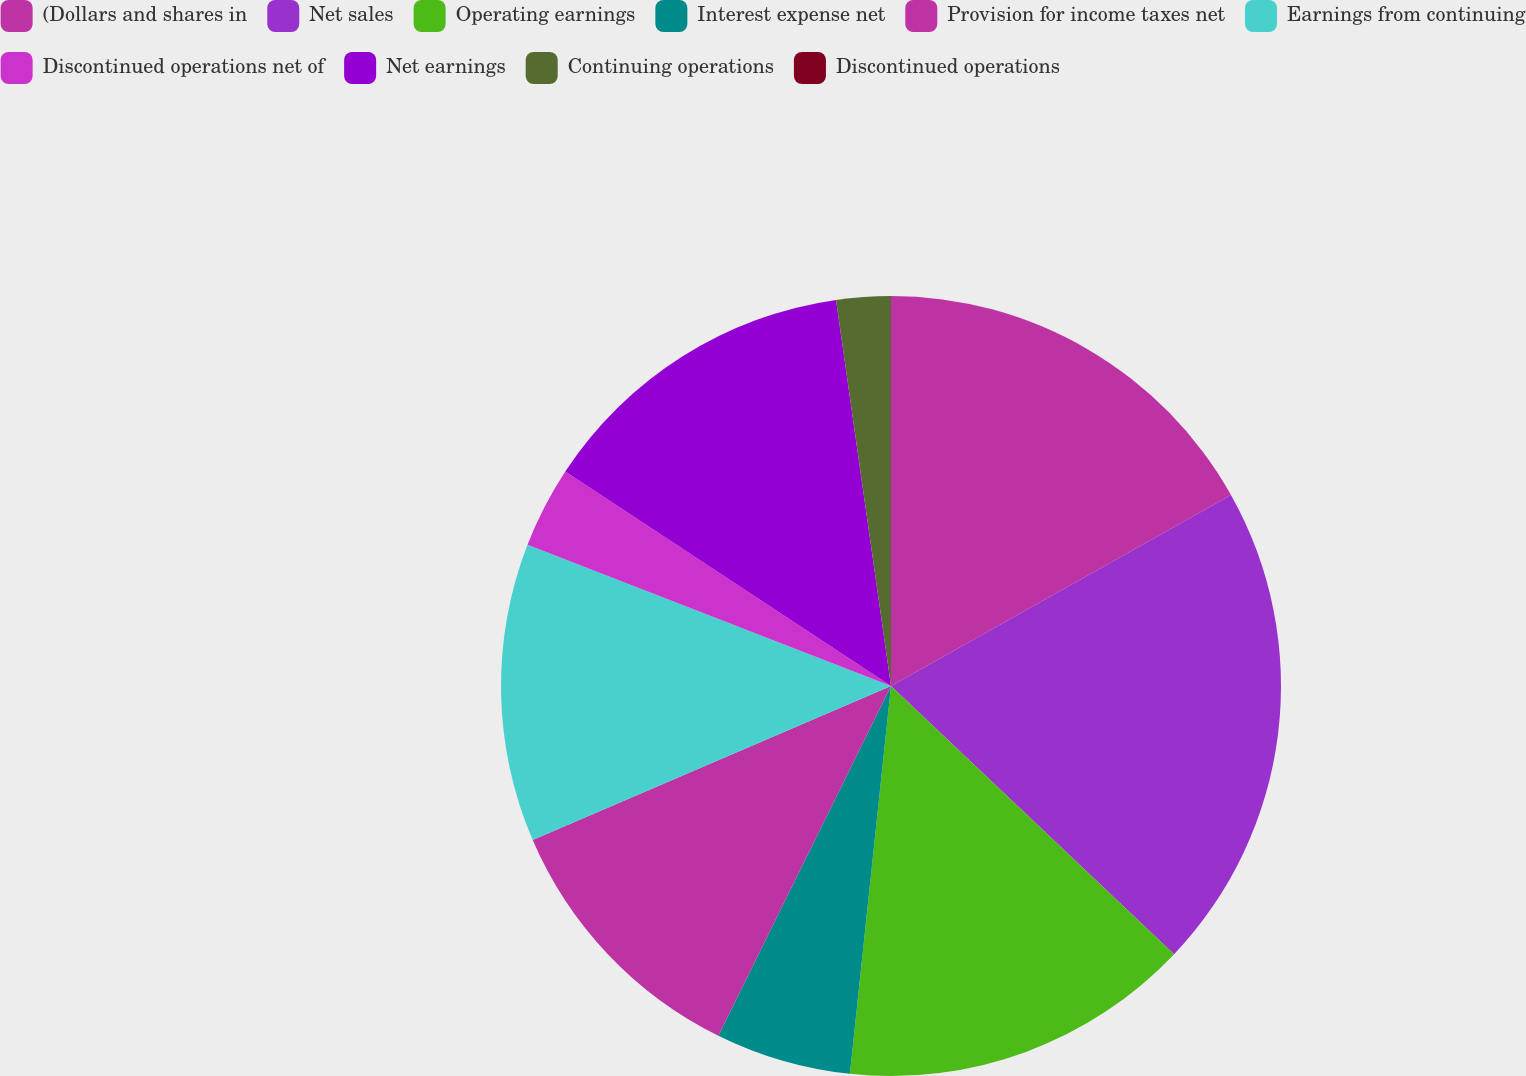Convert chart to OTSL. <chart><loc_0><loc_0><loc_500><loc_500><pie_chart><fcel>(Dollars and shares in<fcel>Net sales<fcel>Operating earnings<fcel>Interest expense net<fcel>Provision for income taxes net<fcel>Earnings from continuing<fcel>Discontinued operations net of<fcel>Net earnings<fcel>Continuing operations<fcel>Discontinued operations<nl><fcel>16.85%<fcel>20.22%<fcel>14.61%<fcel>5.62%<fcel>11.24%<fcel>12.36%<fcel>3.37%<fcel>13.48%<fcel>2.25%<fcel>0.0%<nl></chart> 